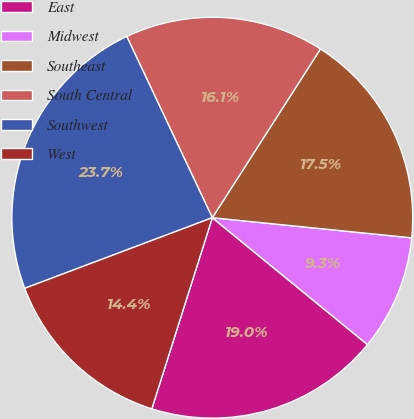<chart> <loc_0><loc_0><loc_500><loc_500><pie_chart><fcel>East<fcel>Midwest<fcel>Southeast<fcel>South Central<fcel>Southwest<fcel>West<nl><fcel>18.97%<fcel>9.31%<fcel>17.53%<fcel>16.09%<fcel>23.71%<fcel>14.39%<nl></chart> 